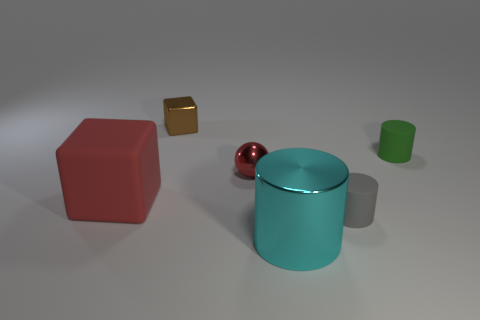There is a rubber thing that is the same color as the metal sphere; what is its shape?
Your answer should be compact. Cube. What is the size of the metallic ball that is the same color as the big matte thing?
Your answer should be very brief. Small. What shape is the big object on the left side of the large cyan metallic thing?
Ensure brevity in your answer.  Cube. There is a tiny cylinder in front of the green matte thing; is there a large red matte cube that is right of it?
Provide a short and direct response. No. There is a tiny object that is both on the left side of the tiny gray rubber object and in front of the green matte cylinder; what color is it?
Provide a short and direct response. Red. Are there any tiny things that are on the right side of the small green matte thing to the right of the block in front of the small metal cube?
Ensure brevity in your answer.  No. There is another matte thing that is the same shape as the green rubber thing; what size is it?
Give a very brief answer. Small. Is there anything else that is made of the same material as the green cylinder?
Keep it short and to the point. Yes. Are there any large blue rubber things?
Provide a succinct answer. No. There is a large cylinder; does it have the same color as the ball to the right of the brown cube?
Provide a short and direct response. No. 